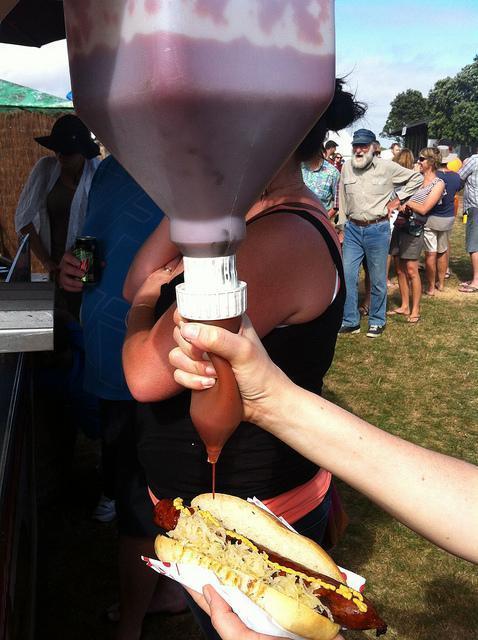How many people are in the picture?
Give a very brief answer. 7. How many green buses can you see?
Give a very brief answer. 0. 